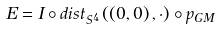<formula> <loc_0><loc_0><loc_500><loc_500>E = I \circ d i s t _ { S ^ { 4 } } \left ( \left ( 0 , 0 \right ) , \cdot \right ) \circ p _ { G M }</formula> 